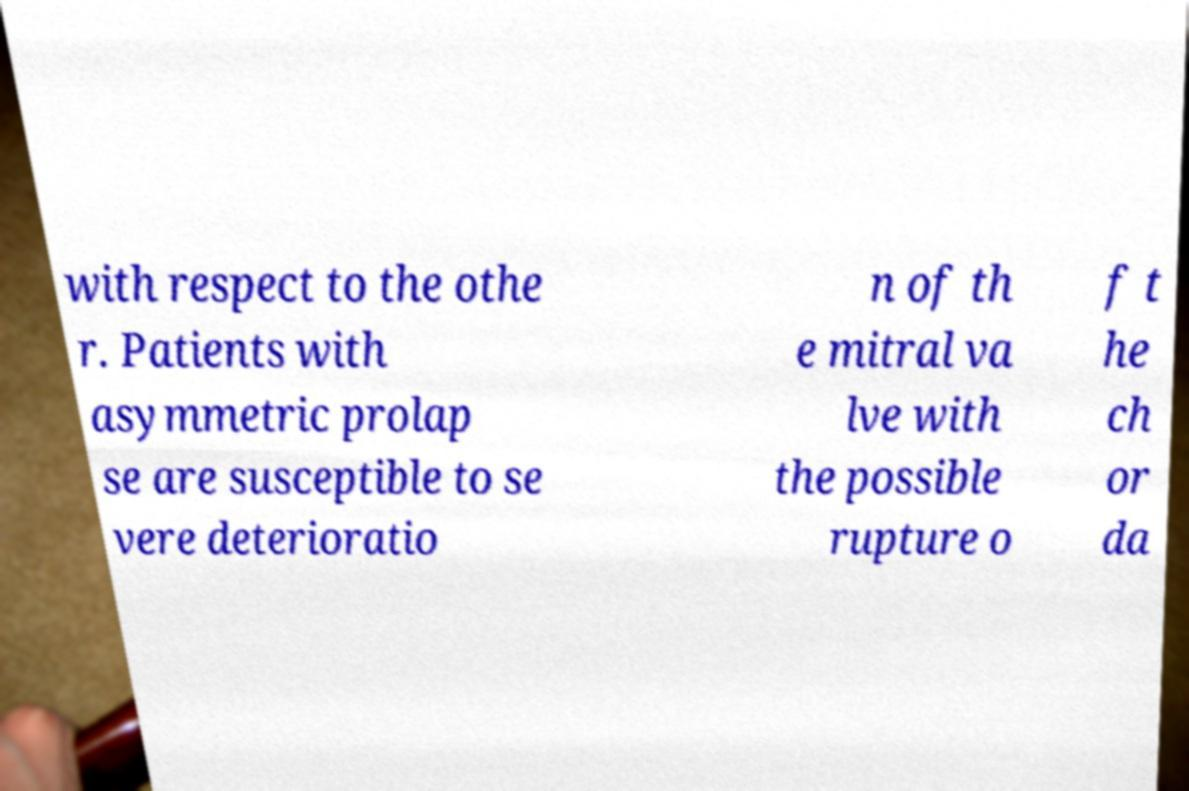Please read and relay the text visible in this image. What does it say? with respect to the othe r. Patients with asymmetric prolap se are susceptible to se vere deterioratio n of th e mitral va lve with the possible rupture o f t he ch or da 